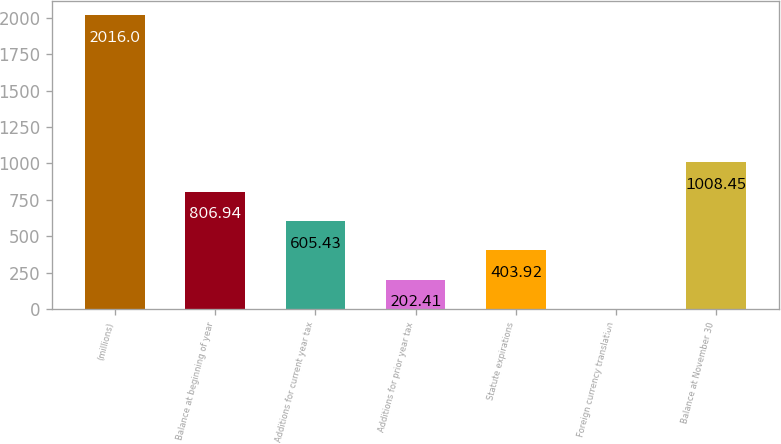Convert chart. <chart><loc_0><loc_0><loc_500><loc_500><bar_chart><fcel>(millions)<fcel>Balance at beginning of year<fcel>Additions for current year tax<fcel>Additions for prior year tax<fcel>Statute expirations<fcel>Foreign currency translation<fcel>Balance at November 30<nl><fcel>2016<fcel>806.94<fcel>605.43<fcel>202.41<fcel>403.92<fcel>0.9<fcel>1008.45<nl></chart> 